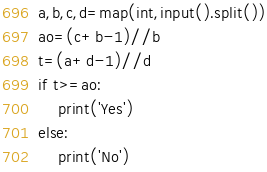<code> <loc_0><loc_0><loc_500><loc_500><_Python_>a,b,c,d=map(int,input().split())
ao=(c+b-1)//b
t=(a+d-1)//d
if t>=ao:
    print('Yes')
else:
    print('No')</code> 